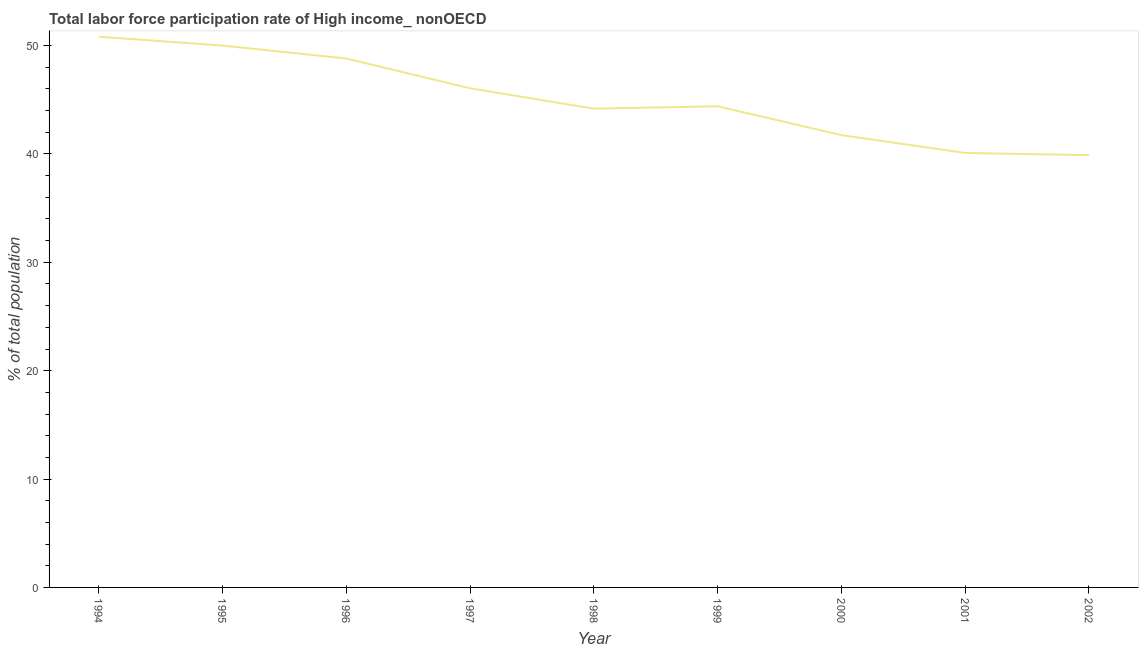What is the total labor force participation rate in 1998?
Offer a terse response. 44.18. Across all years, what is the maximum total labor force participation rate?
Make the answer very short. 50.81. Across all years, what is the minimum total labor force participation rate?
Offer a terse response. 39.89. What is the sum of the total labor force participation rate?
Your answer should be very brief. 405.97. What is the difference between the total labor force participation rate in 1994 and 1999?
Provide a short and direct response. 6.42. What is the average total labor force participation rate per year?
Offer a terse response. 45.11. What is the median total labor force participation rate?
Offer a terse response. 44.4. Do a majority of the years between 1995 and 1999 (inclusive) have total labor force participation rate greater than 10 %?
Provide a short and direct response. Yes. What is the ratio of the total labor force participation rate in 1999 to that in 2001?
Your answer should be compact. 1.11. Is the difference between the total labor force participation rate in 1994 and 2002 greater than the difference between any two years?
Keep it short and to the point. Yes. What is the difference between the highest and the second highest total labor force participation rate?
Your answer should be very brief. 0.81. Is the sum of the total labor force participation rate in 1995 and 1998 greater than the maximum total labor force participation rate across all years?
Offer a very short reply. Yes. What is the difference between the highest and the lowest total labor force participation rate?
Your answer should be very brief. 10.92. Does the graph contain any zero values?
Your answer should be compact. No. Does the graph contain grids?
Make the answer very short. No. What is the title of the graph?
Make the answer very short. Total labor force participation rate of High income_ nonOECD. What is the label or title of the X-axis?
Keep it short and to the point. Year. What is the label or title of the Y-axis?
Give a very brief answer. % of total population. What is the % of total population of 1994?
Your response must be concise. 50.81. What is the % of total population of 1995?
Offer a very short reply. 50. What is the % of total population in 1996?
Provide a short and direct response. 48.8. What is the % of total population in 1997?
Provide a short and direct response. 46.06. What is the % of total population of 1998?
Provide a succinct answer. 44.18. What is the % of total population in 1999?
Keep it short and to the point. 44.4. What is the % of total population in 2000?
Provide a short and direct response. 41.74. What is the % of total population in 2001?
Make the answer very short. 40.09. What is the % of total population in 2002?
Your answer should be very brief. 39.89. What is the difference between the % of total population in 1994 and 1995?
Make the answer very short. 0.81. What is the difference between the % of total population in 1994 and 1996?
Ensure brevity in your answer.  2.01. What is the difference between the % of total population in 1994 and 1997?
Your answer should be compact. 4.75. What is the difference between the % of total population in 1994 and 1998?
Your answer should be compact. 6.64. What is the difference between the % of total population in 1994 and 1999?
Give a very brief answer. 6.42. What is the difference between the % of total population in 1994 and 2000?
Your response must be concise. 9.08. What is the difference between the % of total population in 1994 and 2001?
Provide a succinct answer. 10.72. What is the difference between the % of total population in 1994 and 2002?
Ensure brevity in your answer.  10.92. What is the difference between the % of total population in 1995 and 1996?
Offer a terse response. 1.19. What is the difference between the % of total population in 1995 and 1997?
Your answer should be very brief. 3.94. What is the difference between the % of total population in 1995 and 1998?
Make the answer very short. 5.82. What is the difference between the % of total population in 1995 and 1999?
Provide a succinct answer. 5.6. What is the difference between the % of total population in 1995 and 2000?
Keep it short and to the point. 8.26. What is the difference between the % of total population in 1995 and 2001?
Keep it short and to the point. 9.91. What is the difference between the % of total population in 1995 and 2002?
Offer a terse response. 10.11. What is the difference between the % of total population in 1996 and 1997?
Make the answer very short. 2.75. What is the difference between the % of total population in 1996 and 1998?
Offer a very short reply. 4.63. What is the difference between the % of total population in 1996 and 1999?
Provide a succinct answer. 4.41. What is the difference between the % of total population in 1996 and 2000?
Make the answer very short. 7.07. What is the difference between the % of total population in 1996 and 2001?
Provide a succinct answer. 8.71. What is the difference between the % of total population in 1996 and 2002?
Offer a very short reply. 8.92. What is the difference between the % of total population in 1997 and 1998?
Keep it short and to the point. 1.88. What is the difference between the % of total population in 1997 and 1999?
Offer a very short reply. 1.66. What is the difference between the % of total population in 1997 and 2000?
Give a very brief answer. 4.32. What is the difference between the % of total population in 1997 and 2001?
Keep it short and to the point. 5.97. What is the difference between the % of total population in 1997 and 2002?
Provide a short and direct response. 6.17. What is the difference between the % of total population in 1998 and 1999?
Offer a very short reply. -0.22. What is the difference between the % of total population in 1998 and 2000?
Offer a very short reply. 2.44. What is the difference between the % of total population in 1998 and 2001?
Offer a very short reply. 4.09. What is the difference between the % of total population in 1998 and 2002?
Ensure brevity in your answer.  4.29. What is the difference between the % of total population in 1999 and 2000?
Give a very brief answer. 2.66. What is the difference between the % of total population in 1999 and 2001?
Your response must be concise. 4.31. What is the difference between the % of total population in 1999 and 2002?
Keep it short and to the point. 4.51. What is the difference between the % of total population in 2000 and 2001?
Provide a short and direct response. 1.65. What is the difference between the % of total population in 2000 and 2002?
Offer a very short reply. 1.85. What is the difference between the % of total population in 2001 and 2002?
Provide a succinct answer. 0.2. What is the ratio of the % of total population in 1994 to that in 1996?
Keep it short and to the point. 1.04. What is the ratio of the % of total population in 1994 to that in 1997?
Your answer should be compact. 1.1. What is the ratio of the % of total population in 1994 to that in 1998?
Give a very brief answer. 1.15. What is the ratio of the % of total population in 1994 to that in 1999?
Make the answer very short. 1.15. What is the ratio of the % of total population in 1994 to that in 2000?
Offer a very short reply. 1.22. What is the ratio of the % of total population in 1994 to that in 2001?
Keep it short and to the point. 1.27. What is the ratio of the % of total population in 1994 to that in 2002?
Your response must be concise. 1.27. What is the ratio of the % of total population in 1995 to that in 1997?
Offer a terse response. 1.09. What is the ratio of the % of total population in 1995 to that in 1998?
Offer a terse response. 1.13. What is the ratio of the % of total population in 1995 to that in 1999?
Offer a very short reply. 1.13. What is the ratio of the % of total population in 1995 to that in 2000?
Provide a short and direct response. 1.2. What is the ratio of the % of total population in 1995 to that in 2001?
Make the answer very short. 1.25. What is the ratio of the % of total population in 1995 to that in 2002?
Provide a succinct answer. 1.25. What is the ratio of the % of total population in 1996 to that in 1997?
Keep it short and to the point. 1.06. What is the ratio of the % of total population in 1996 to that in 1998?
Keep it short and to the point. 1.1. What is the ratio of the % of total population in 1996 to that in 1999?
Offer a very short reply. 1.1. What is the ratio of the % of total population in 1996 to that in 2000?
Offer a terse response. 1.17. What is the ratio of the % of total population in 1996 to that in 2001?
Your answer should be compact. 1.22. What is the ratio of the % of total population in 1996 to that in 2002?
Ensure brevity in your answer.  1.22. What is the ratio of the % of total population in 1997 to that in 1998?
Your response must be concise. 1.04. What is the ratio of the % of total population in 1997 to that in 2000?
Make the answer very short. 1.1. What is the ratio of the % of total population in 1997 to that in 2001?
Your response must be concise. 1.15. What is the ratio of the % of total population in 1997 to that in 2002?
Provide a short and direct response. 1.16. What is the ratio of the % of total population in 1998 to that in 2000?
Offer a very short reply. 1.06. What is the ratio of the % of total population in 1998 to that in 2001?
Offer a terse response. 1.1. What is the ratio of the % of total population in 1998 to that in 2002?
Ensure brevity in your answer.  1.11. What is the ratio of the % of total population in 1999 to that in 2000?
Keep it short and to the point. 1.06. What is the ratio of the % of total population in 1999 to that in 2001?
Provide a succinct answer. 1.11. What is the ratio of the % of total population in 1999 to that in 2002?
Give a very brief answer. 1.11. What is the ratio of the % of total population in 2000 to that in 2001?
Your answer should be compact. 1.04. What is the ratio of the % of total population in 2000 to that in 2002?
Ensure brevity in your answer.  1.05. 